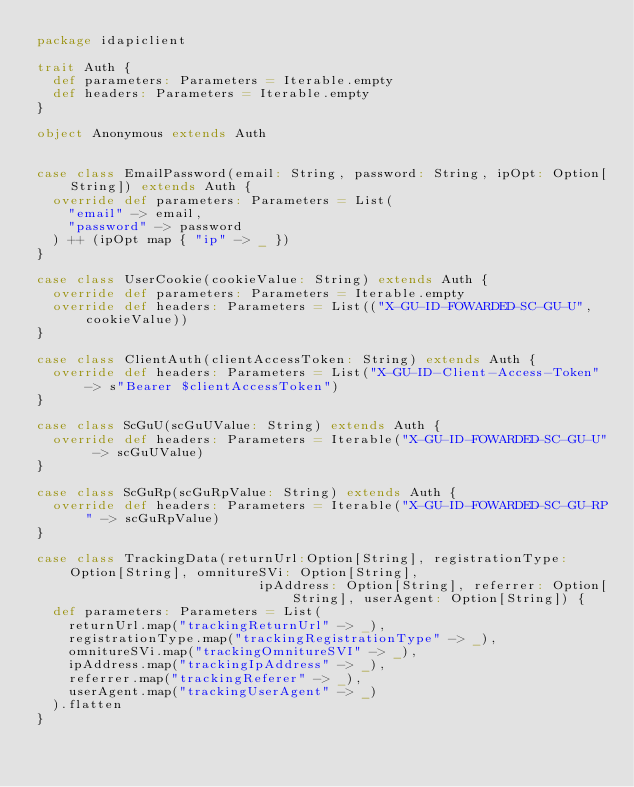<code> <loc_0><loc_0><loc_500><loc_500><_Scala_>package idapiclient

trait Auth {
  def parameters: Parameters = Iterable.empty
  def headers: Parameters = Iterable.empty
}

object Anonymous extends Auth


case class EmailPassword(email: String, password: String, ipOpt: Option[String]) extends Auth {
  override def parameters: Parameters = List(
    "email" -> email,
    "password" -> password
  ) ++ (ipOpt map { "ip" -> _ })
}

case class UserCookie(cookieValue: String) extends Auth {
  override def parameters: Parameters = Iterable.empty
  override def headers: Parameters = List(("X-GU-ID-FOWARDED-SC-GU-U", cookieValue))
}

case class ClientAuth(clientAccessToken: String) extends Auth {
  override def headers: Parameters = List("X-GU-ID-Client-Access-Token" -> s"Bearer $clientAccessToken")
}

case class ScGuU(scGuUValue: String) extends Auth {
  override def headers: Parameters = Iterable("X-GU-ID-FOWARDED-SC-GU-U" -> scGuUValue)
}

case class ScGuRp(scGuRpValue: String) extends Auth {
  override def headers: Parameters = Iterable("X-GU-ID-FOWARDED-SC-GU-RP" -> scGuRpValue)
}

case class TrackingData(returnUrl:Option[String], registrationType: Option[String], omnitureSVi: Option[String],
                            ipAddress: Option[String], referrer: Option[String], userAgent: Option[String]) {
  def parameters: Parameters = List(
    returnUrl.map("trackingReturnUrl" -> _),
    registrationType.map("trackingRegistrationType" -> _),
    omnitureSVi.map("trackingOmnitureSVI" -> _),
    ipAddress.map("trackingIpAddress" -> _),
    referrer.map("trackingReferer" -> _),
    userAgent.map("trackingUserAgent" -> _)
  ).flatten
}
</code> 